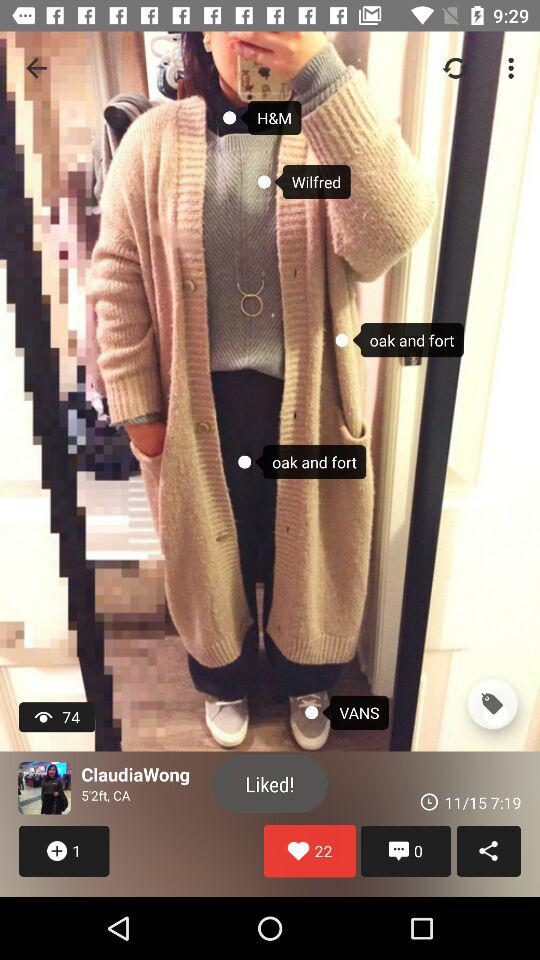How many more likes does the post have than comments?
Answer the question using a single word or phrase. 22 